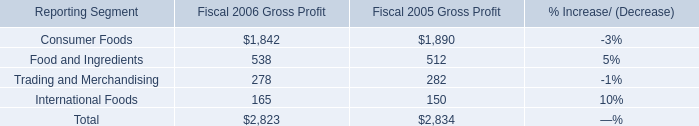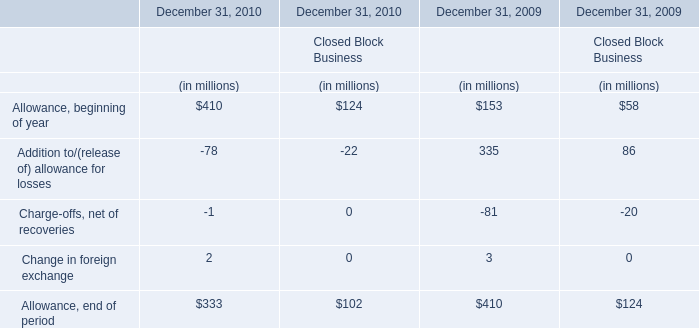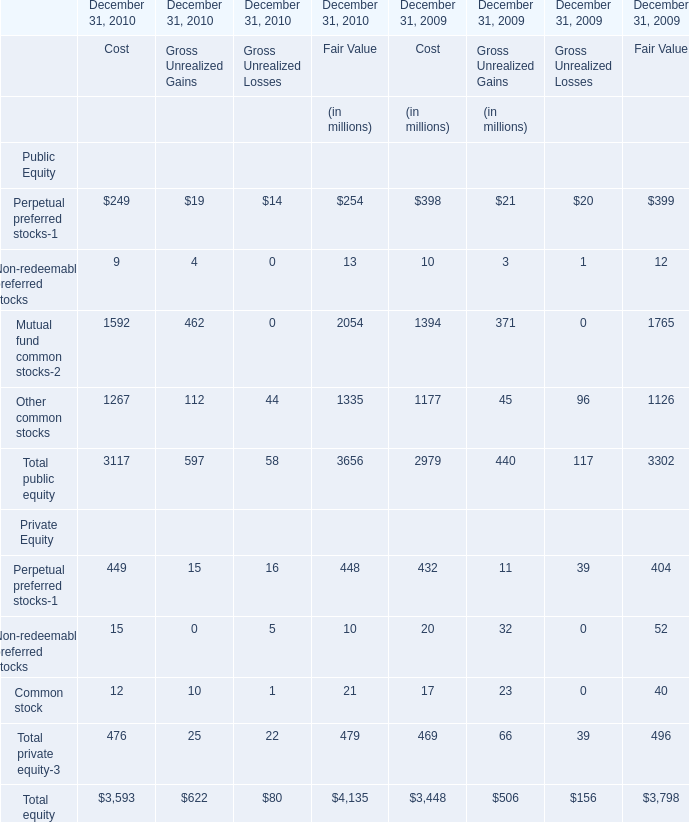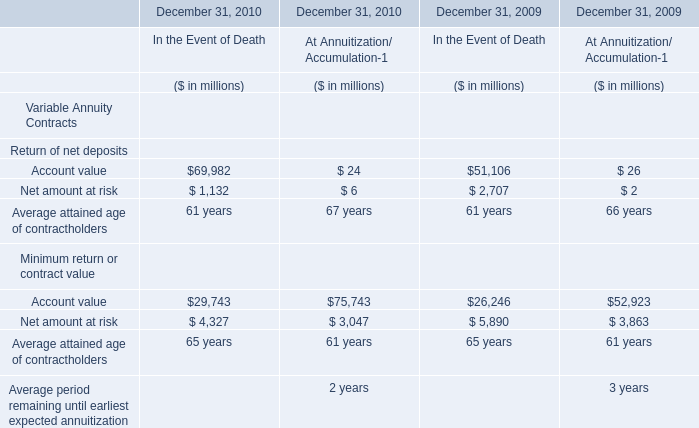In the year with largest amount of Change in foreign exchange for financial services businesses, what's the sum of financial services businesses? (in million) 
Computations: (((153 + 335) - 81) + 3)
Answer: 410.0. 